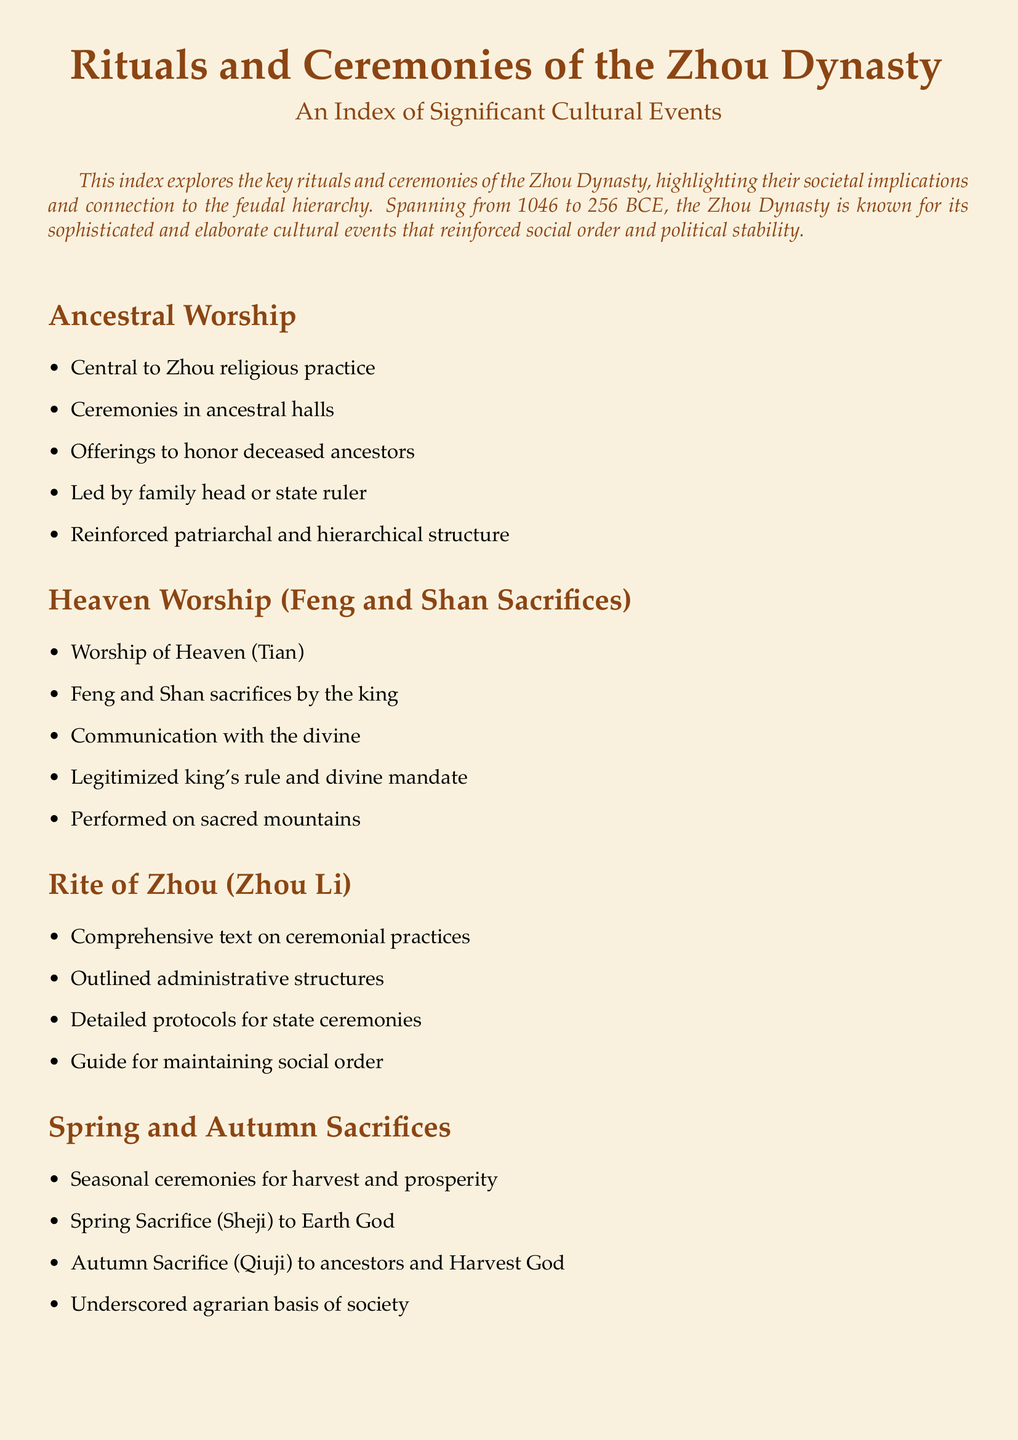What is central to Zhou religious practice? Ancestral worship is highlighted as the central aspect of Zhou religious practice in the document.
Answer: Ancestral worship Who performed the Feng and Shan sacrifices? The document states that these sacrifices are performed by the king.
Answer: King What text outlines ceremonial practices in the Zhou Dynasty? The document mentions the Rite of Zhou (Zhou Li) as the comprehensive text on ceremonial practices.
Answer: Rite of Zhou (Zhou Li) What seasonal ceremonies are associated with harvest and prosperity? The document specifies the Spring Sacrifice (Sheji) and Autumn Sacrifice (Qiuji) as the seasonal ceremonies.
Answer: Spring Sacrifice (Sheji) and Autumn Sacrifice (Qiuji) What role does music play in Zhou rituals? According to the document, music symbolizes harmony and order during Zhou ceremonies.
Answer: Harmony and order What significant social events are described in the document? The document indicates that formal banquets are significant social and political events.
Answer: Formal banquets What cultural aspect does the 'Yayue' represent in Zhou ceremonies? The document states that 'Yayue' represents elegant music crucial to the rituals.
Answer: Elegant music What purpose do ancestral offerings serve? The document mentions that offerings honor deceased ancestors, serving a specific societal role in the rituals.
Answer: Honor deceased ancestors 